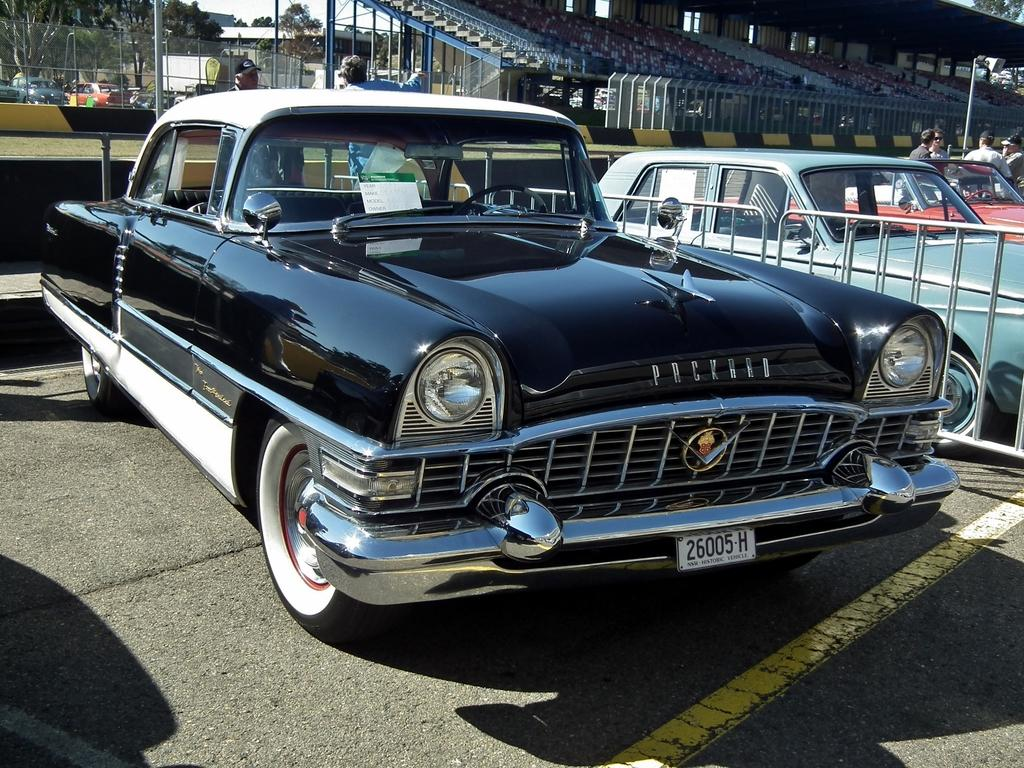What is blocking the path in the image? There is a barricade in the image. What type of vehicles can be seen in the image? Cars are present in the image. Where are the persons located in the image? The persons are in the top right of the image. What structure can be seen in the top right of the image? There is a shelter in the top right of the image. What type of bed is visible in the image? There is no bed present in the image. What kind of furniture can be seen in the image? There is no furniture present in the image. 